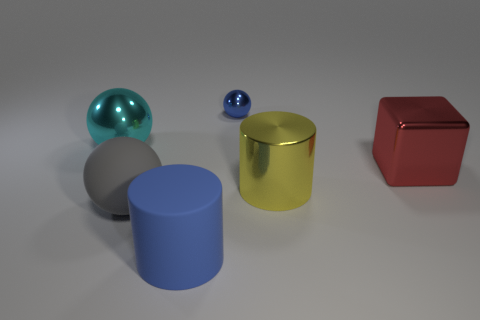Are there any matte things on the right side of the large red shiny block?
Offer a very short reply. No. What color is the block?
Provide a short and direct response. Red. There is a large shiny ball; is its color the same as the big sphere that is in front of the red metal block?
Your answer should be very brief. No. Are there any metallic balls of the same size as the metallic block?
Ensure brevity in your answer.  Yes. There is another rubber object that is the same color as the small object; what size is it?
Your answer should be very brief. Large. What is the material of the blue object behind the blue matte thing?
Offer a terse response. Metal. Are there an equal number of cyan metallic balls that are behind the cyan sphere and blue cylinders behind the red object?
Give a very brief answer. Yes. Does the shiny sphere that is on the right side of the cyan metallic thing have the same size as the sphere in front of the big metal cylinder?
Ensure brevity in your answer.  No. How many matte balls have the same color as the metal block?
Give a very brief answer. 0. There is a big thing that is the same color as the tiny sphere; what is its material?
Offer a terse response. Rubber. 